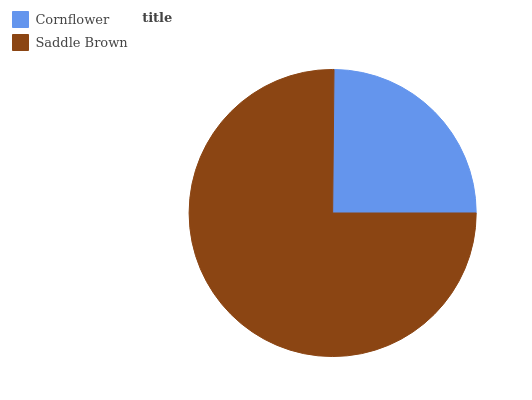Is Cornflower the minimum?
Answer yes or no. Yes. Is Saddle Brown the maximum?
Answer yes or no. Yes. Is Saddle Brown the minimum?
Answer yes or no. No. Is Saddle Brown greater than Cornflower?
Answer yes or no. Yes. Is Cornflower less than Saddle Brown?
Answer yes or no. Yes. Is Cornflower greater than Saddle Brown?
Answer yes or no. No. Is Saddle Brown less than Cornflower?
Answer yes or no. No. Is Saddle Brown the high median?
Answer yes or no. Yes. Is Cornflower the low median?
Answer yes or no. Yes. Is Cornflower the high median?
Answer yes or no. No. Is Saddle Brown the low median?
Answer yes or no. No. 